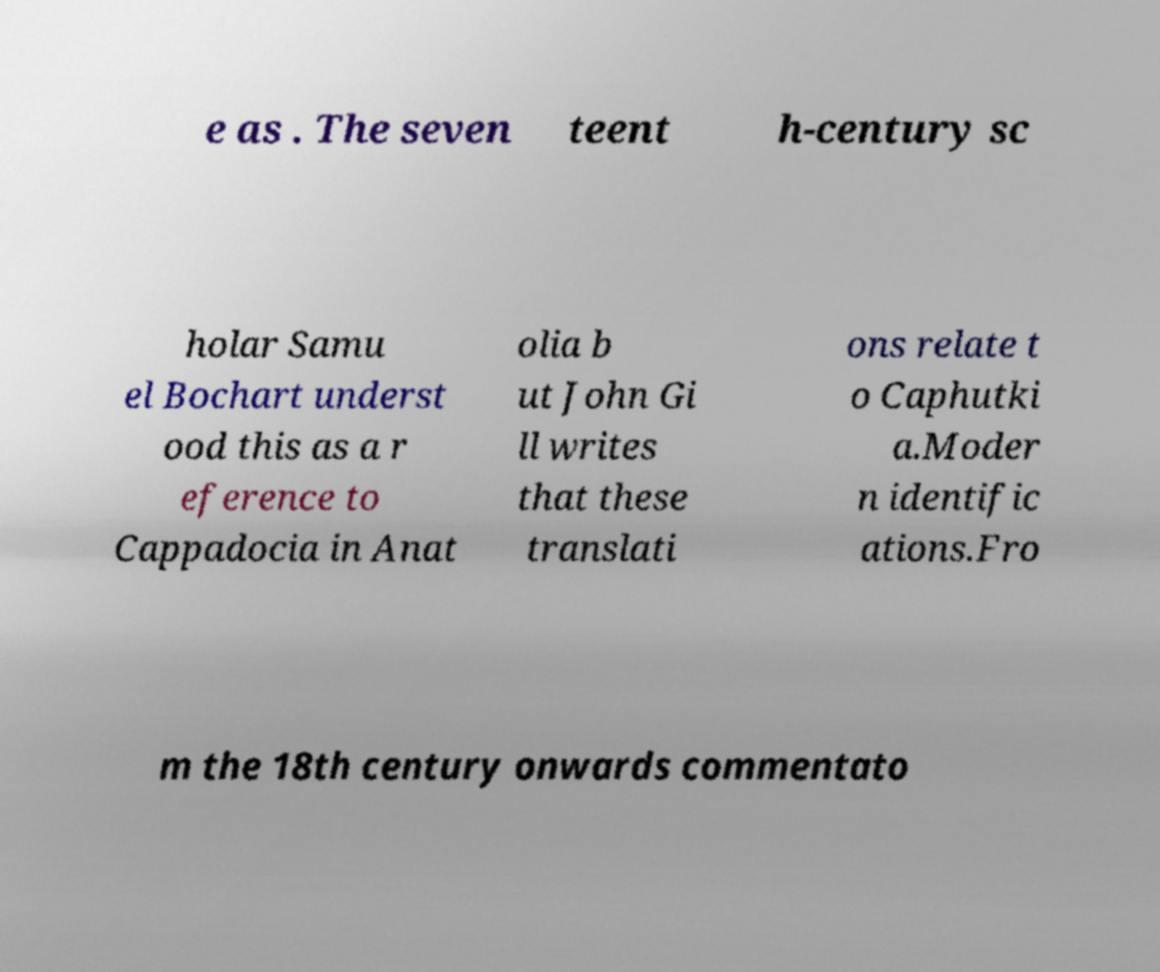Could you assist in decoding the text presented in this image and type it out clearly? e as . The seven teent h-century sc holar Samu el Bochart underst ood this as a r eference to Cappadocia in Anat olia b ut John Gi ll writes that these translati ons relate t o Caphutki a.Moder n identific ations.Fro m the 18th century onwards commentato 